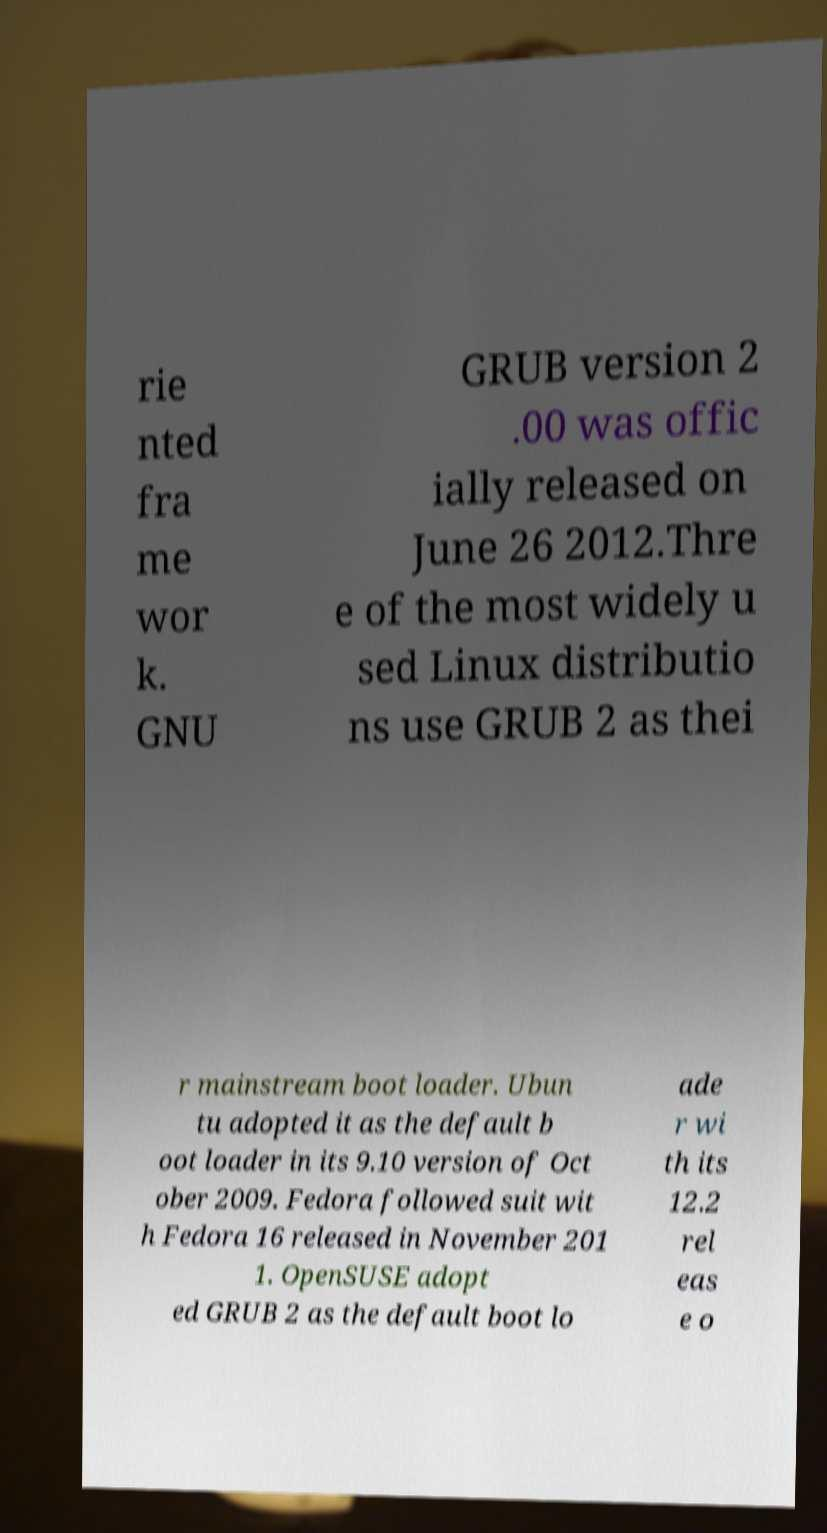Could you assist in decoding the text presented in this image and type it out clearly? rie nted fra me wor k. GNU GRUB version 2 .00 was offic ially released on June 26 2012.Thre e of the most widely u sed Linux distributio ns use GRUB 2 as thei r mainstream boot loader. Ubun tu adopted it as the default b oot loader in its 9.10 version of Oct ober 2009. Fedora followed suit wit h Fedora 16 released in November 201 1. OpenSUSE adopt ed GRUB 2 as the default boot lo ade r wi th its 12.2 rel eas e o 